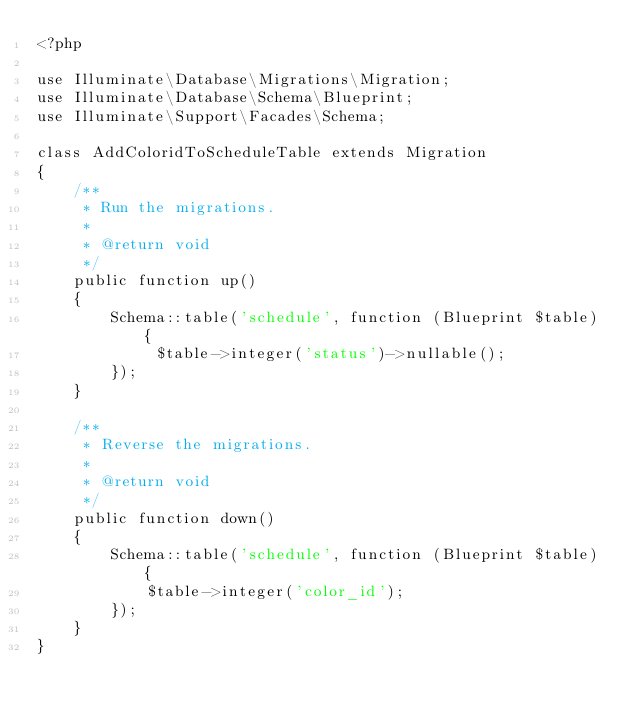Convert code to text. <code><loc_0><loc_0><loc_500><loc_500><_PHP_><?php

use Illuminate\Database\Migrations\Migration;
use Illuminate\Database\Schema\Blueprint;
use Illuminate\Support\Facades\Schema;

class AddColoridToScheduleTable extends Migration
{
    /**
     * Run the migrations.
     *
     * @return void
     */
    public function up()
    {
        Schema::table('schedule', function (Blueprint $table) {
             $table->integer('status')->nullable();
        });
    }

    /**
     * Reverse the migrations.
     *
     * @return void
     */
    public function down()
    {
        Schema::table('schedule', function (Blueprint $table) {
            $table->integer('color_id');
        });
    }
}
</code> 